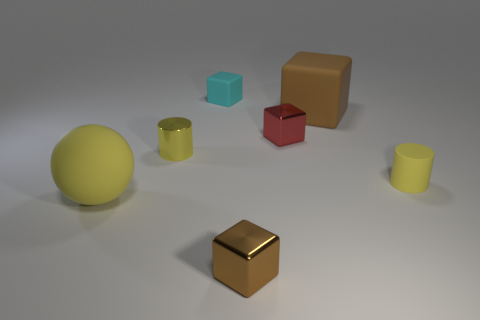Subtract all cyan cubes. How many cubes are left? 3 Add 1 small rubber cubes. How many objects exist? 8 Subtract all cyan blocks. How many blocks are left? 3 Subtract 2 cylinders. How many cylinders are left? 0 Subtract all tiny shiny objects. Subtract all metal blocks. How many objects are left? 2 Add 4 big cubes. How many big cubes are left? 5 Add 1 tiny blue shiny spheres. How many tiny blue shiny spheres exist? 1 Subtract 0 green cylinders. How many objects are left? 7 Subtract all cylinders. How many objects are left? 5 Subtract all blue cylinders. Subtract all yellow cubes. How many cylinders are left? 2 